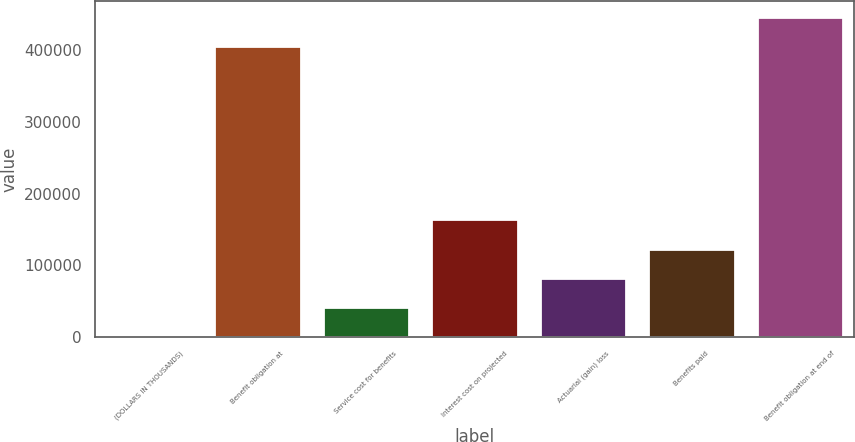Convert chart to OTSL. <chart><loc_0><loc_0><loc_500><loc_500><bar_chart><fcel>(DOLLARS IN THOUSANDS)<fcel>Benefit obligation at<fcel>Service cost for benefits<fcel>Interest cost on projected<fcel>Actuarial (gain) loss<fcel>Benefits paid<fcel>Benefit obligation at end of<nl><fcel>2009<fcel>404902<fcel>42498.2<fcel>163966<fcel>82987.4<fcel>123477<fcel>445391<nl></chart> 